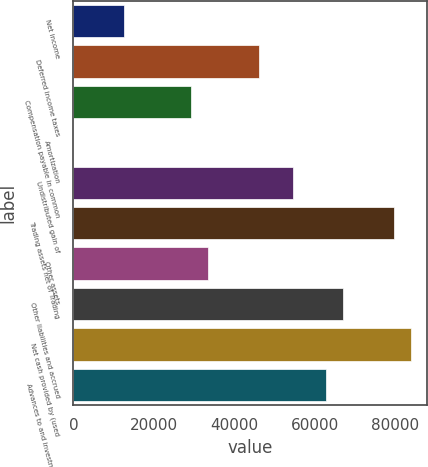<chart> <loc_0><loc_0><loc_500><loc_500><bar_chart><fcel>Net income<fcel>Deferred income taxes<fcel>Compensation payable in common<fcel>Amortization<fcel>Undistributed gain of<fcel>Trading assets net of Trading<fcel>Other assets<fcel>Other liabilities and accrued<fcel>Net cash provided by (used<fcel>Advances to and investments in<nl><fcel>12590.3<fcel>46103.1<fcel>29346.7<fcel>23<fcel>54481.3<fcel>79615.9<fcel>33535.8<fcel>67048.6<fcel>83805<fcel>62859.5<nl></chart> 